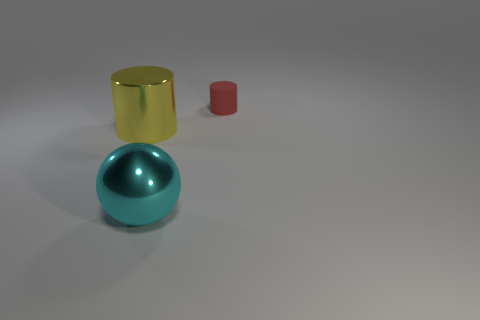The metal sphere is what color? cyan 